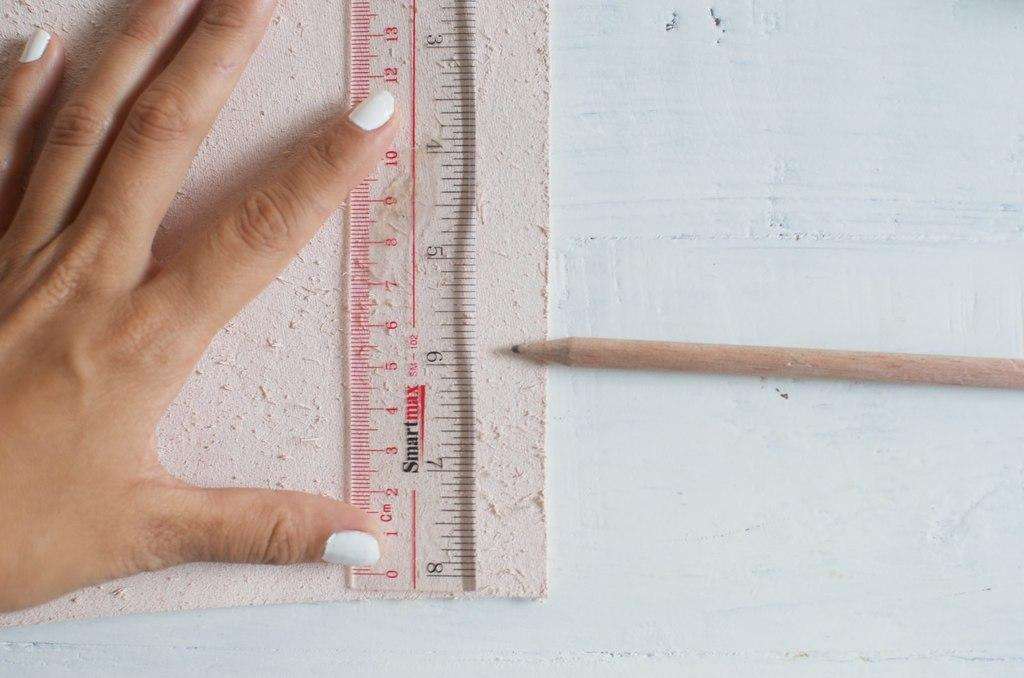<image>
Render a clear and concise summary of the photo. A piece of textured paper that is five and a half inches in length. 